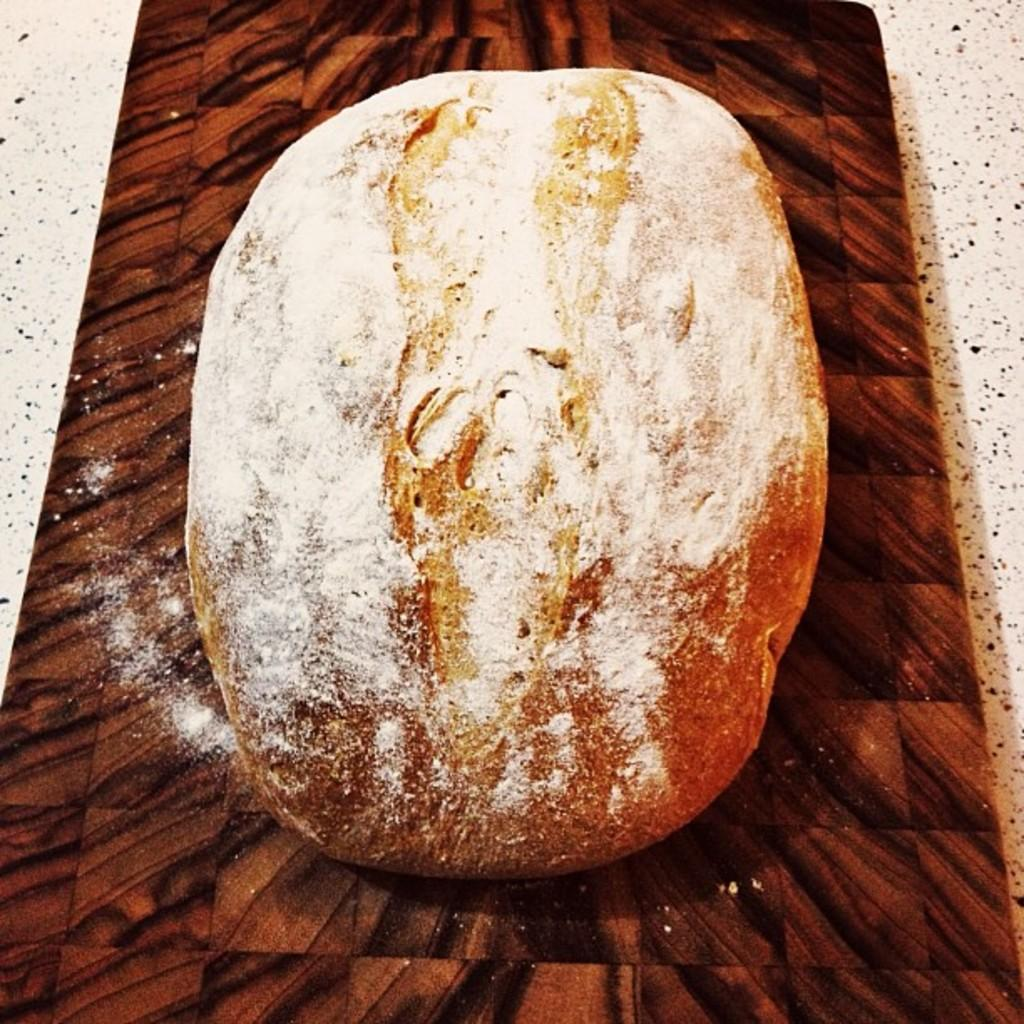What type of food item is visible in the image? There is a food item in the image, but its specific type cannot be determined from the provided facts. What color is the food item in the image? The food item is brown in color. Are there any other brown color objects in the image? Yes, there is a brown color object in the image. Can you see a ring on the tongue of the horn in the image? There is no ring, tongue, or horn present in the image. 